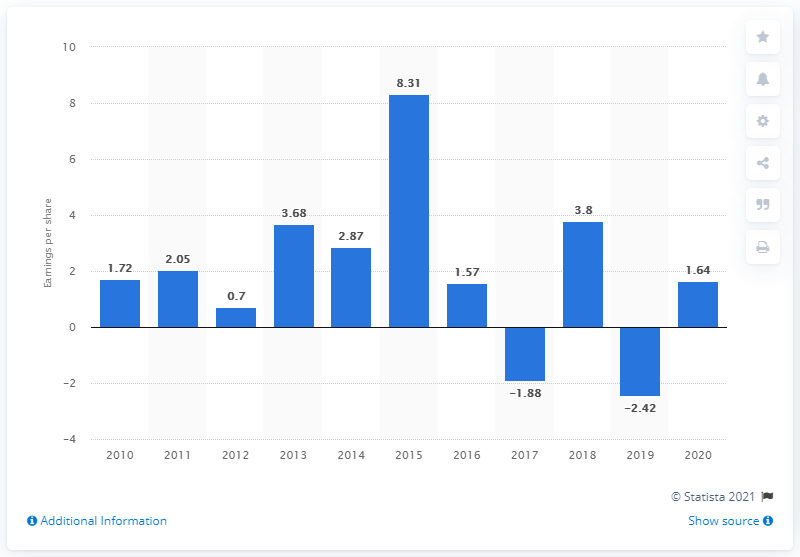Mention a couple of crucial points in this snapshot. In 2020, the earnings per Dow share were 1.64. 